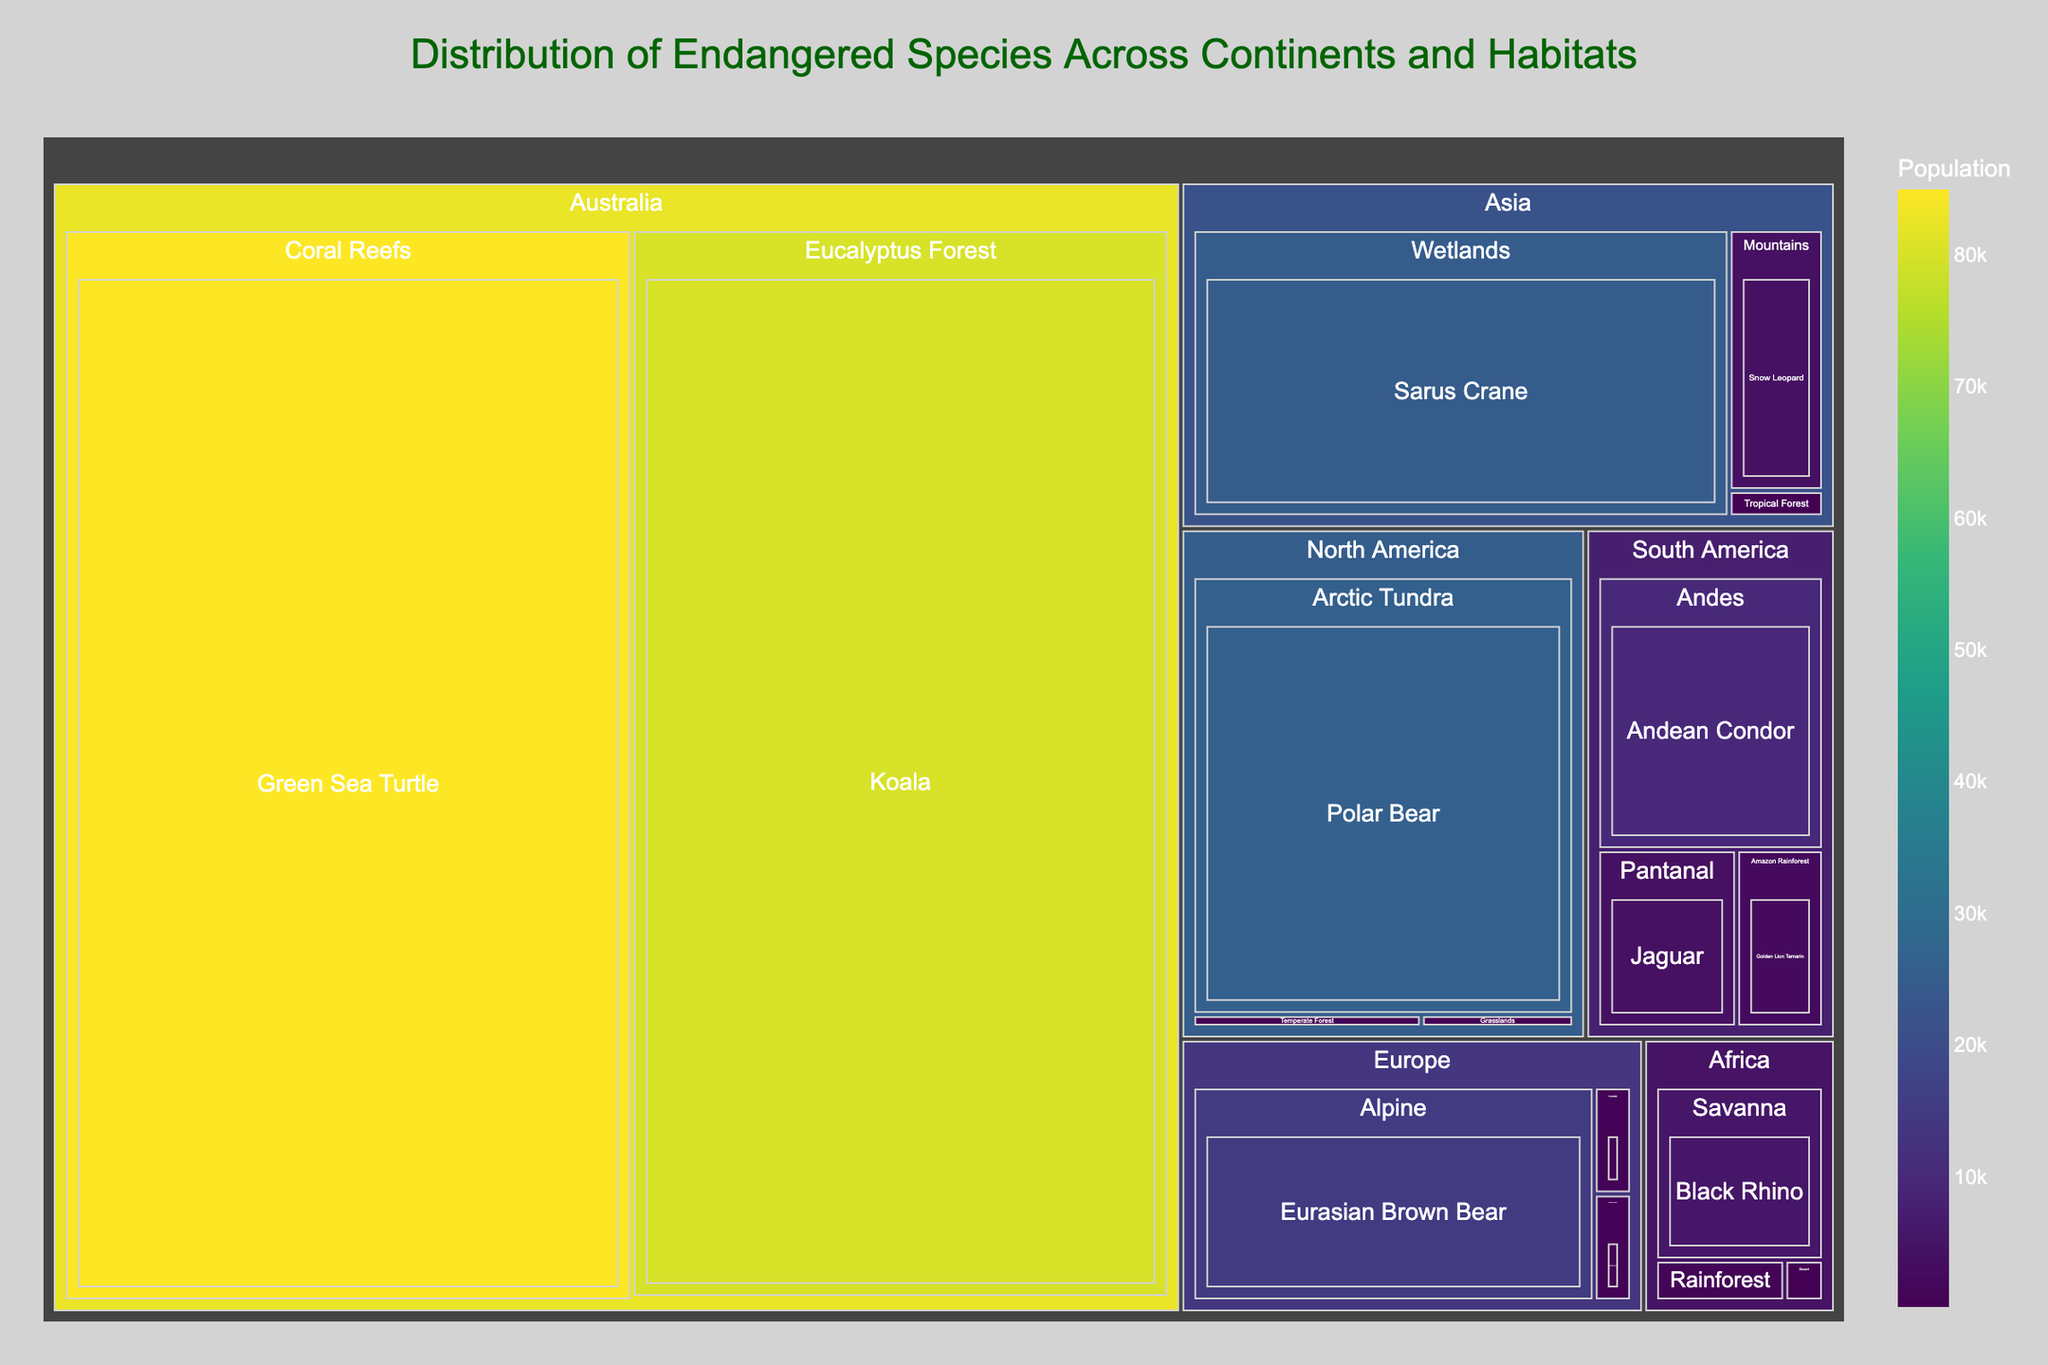What's the title of the figure? The title of the figure is always located at the top and is usually highlighted in a larger or bolder font to make it easily identifiable. By looking directly at the top of the figure, you can see the title text.
Answer: Distribution of Endangered Species Across Continents and Habitats Which continent has the highest population of endangered species? To determine this, you need to look at the sizes of the boxes representing the continents in the treemap. The larger the box, the higher the population of endangered species.
Answer: Australia What is the population of Polar Bears in North America? For this, look for North America in the treemap, then find the habitat "Arctic Tundra" within it. The population is displayed within the box representing Polar Bears.
Answer: 26,000 Compare the population of endangered species in the Savanna of Africa and the Amazon Rainforest of South America. Which one is higher? First, find the Savanna in Africa and note its total population. Then, locate the Amazon Rainforest in South America and check its population. Compare the two numbers.
Answer: Savanna (5,500) has a higher population than Amazon Rainforest (2,500) What is the total population of endangered species in Asia? Sum the populations of all species found within the different habitats in Asia. This includes Sumatran Tiger, Sarus Crane, and Snow Leopard: 400 + 25,000 + 4,000.
Answer: 29,400 Which habitat in Europe has the highest population of endangered species? Look for the largest box under Europe in the treemap, which represents the habitat with the highest population.
Answer: Alpine Compare the population of Mountain Gorillas in Africa and the population of Jaguars in South America. Which population is larger? Find Mountain Gorillas in the Rainforest habitat in Africa and note its population. Then find Jaguars in the Pantanal habitat in South America and compare the two numbers.
Answer: Jaguars (4,000) have a larger population than Mountain Gorillas (1,000) What is the average population of endangered species across the three habitats in North America? To find the average, first sum the populations of the three habitats in North America (Polar Bear: 26,000, Black-footed Ferret: 300, California Condor: 450). Then divide the total by the number of habitats. (26,000 + 300 + 450) / 3.
Answer: 8,250 What is the most populous endangered species found in the dataset? Identify the species with the largest population value in the treemap by comparing all species populations across all continents and habitats.
Answer: Koala Which continent has the lowest overall population of endangered species? Determine this by finding the box representing each continent and looking at the total size or summing up the population values shown. Compare to find the smallest total value.
Answer: Europe 